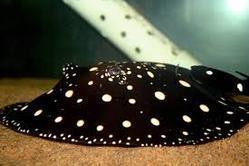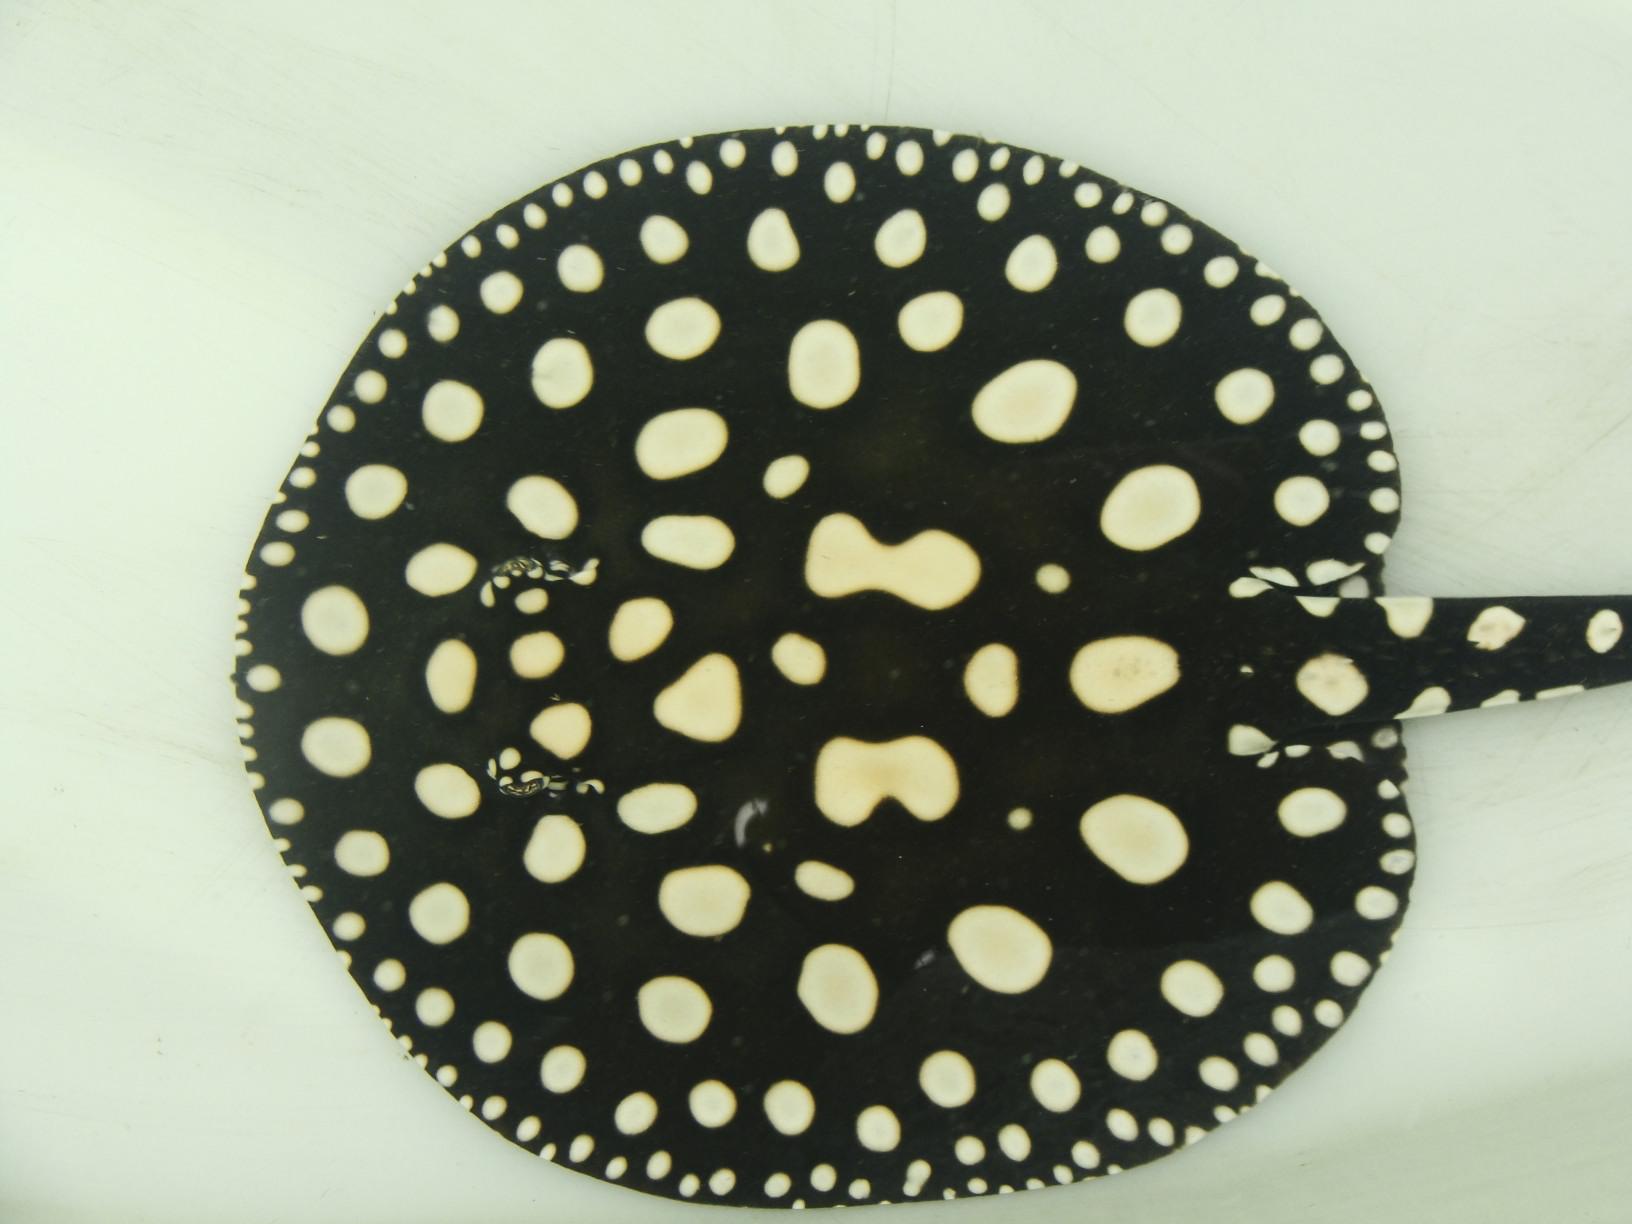The first image is the image on the left, the second image is the image on the right. Considering the images on both sides, is "There are two stingrays." valid? Answer yes or no. Yes. 